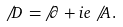Convert formula to latex. <formula><loc_0><loc_0><loc_500><loc_500>\not \, D \, = \, \not \, \partial + i e \not \, A \, .</formula> 